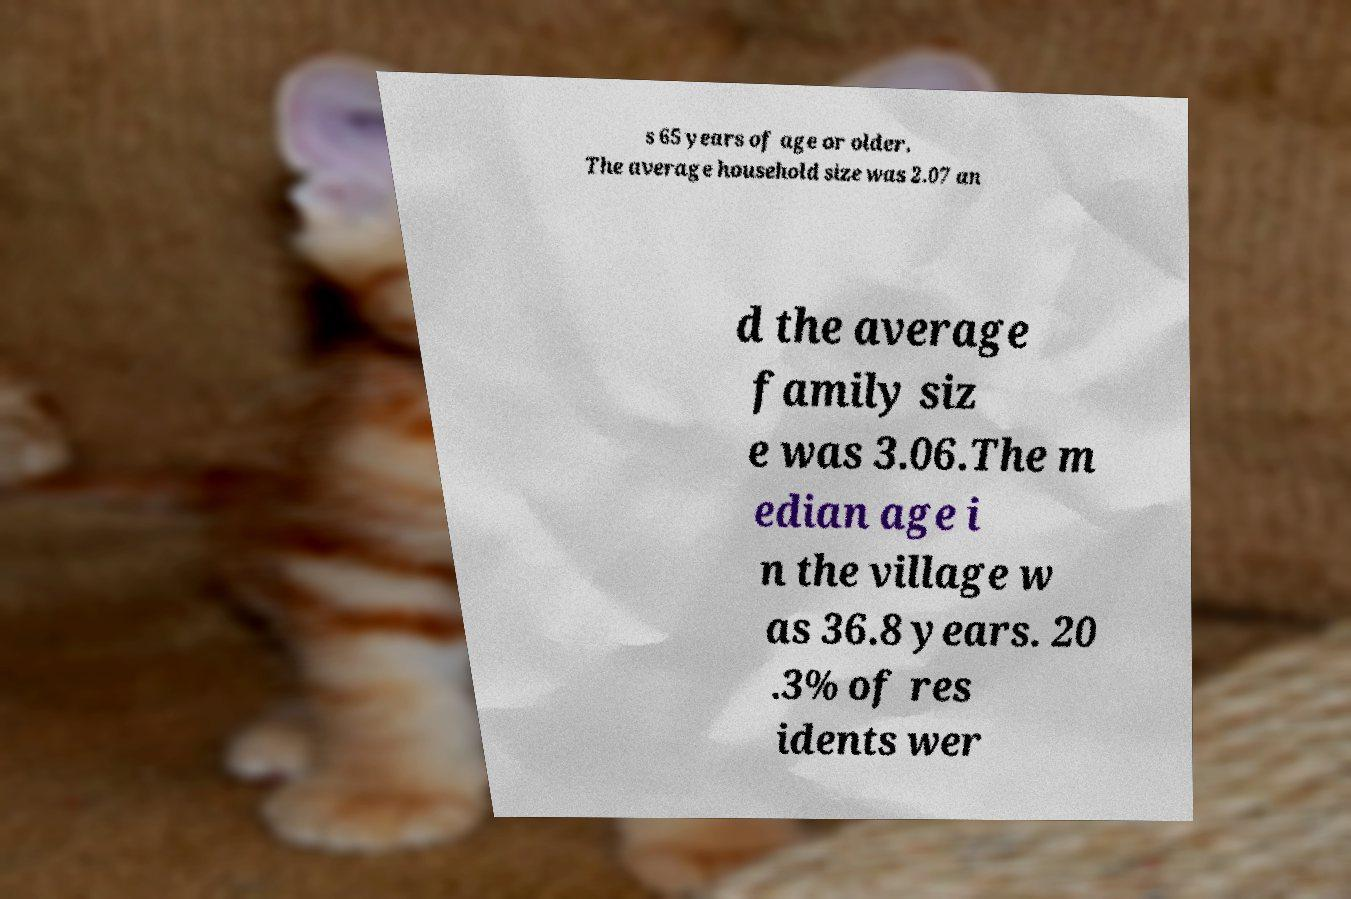Could you assist in decoding the text presented in this image and type it out clearly? s 65 years of age or older. The average household size was 2.07 an d the average family siz e was 3.06.The m edian age i n the village w as 36.8 years. 20 .3% of res idents wer 